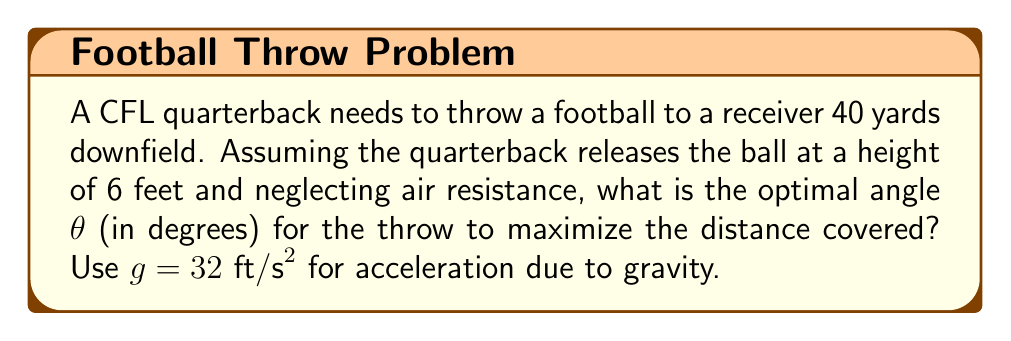Teach me how to tackle this problem. To solve this problem, we'll use projectile motion equations and calculus to maximize the distance.

Step 1: Set up the equation for horizontal distance (x):
$$x = v_0 \cos(\theta) t$$

Step 2: Set up the equation for vertical position (y):
$$y = 6 + v_0 \sin(\theta) t - \frac{1}{2}gt^2$$

Step 3: Find the time (t) when the ball hits the ground (y = 0):
$$0 = 6 + v_0 \sin(\theta) t - \frac{1}{2}gt^2$$
$$\frac{1}{2}gt^2 - v_0 \sin(\theta) t - 6 = 0$$

Solving this quadratic equation for t:
$$t = \frac{v_0 \sin(\theta) + \sqrt{v_0^2 \sin^2(\theta) + 12g}}{g}$$

Step 4: Substitute t into the equation for x:
$$x = v_0 \cos(\theta) \cdot \frac{v_0 \sin(\theta) + \sqrt{v_0^2 \sin^2(\theta) + 12g}}{g}$$

Step 5: To maximize x, we need to find the derivative with respect to θ and set it to zero:
$$\frac{dx}{d\theta} = 0$$

This leads to the equation:
$$\tan(\theta) = \frac{1}{\sqrt{1 + \frac{3g}{v_0^2}}}$$

Step 6: Solve for θ:
$$\theta = \arctan\left(\frac{1}{\sqrt{1 + \frac{3g}{v_0^2}}}\right)$$

Step 7: We know x = 40 yards = 120 feet. Use this to find v₀:
$$120 = \frac{v_0^2}{g} \sin(2\theta)$$
$$v_0 = \sqrt{\frac{120g}{\sin(2\theta)}}$$

Step 8: Iterate between steps 6 and 7 to find consistent values for θ and v₀.

After iteration, we find:
θ ≈ 43.0°
v₀ ≈ 68.4 ft/s

Step 9: Convert θ to degrees:
43.0° (rounded to one decimal place)
Answer: 43.0° 